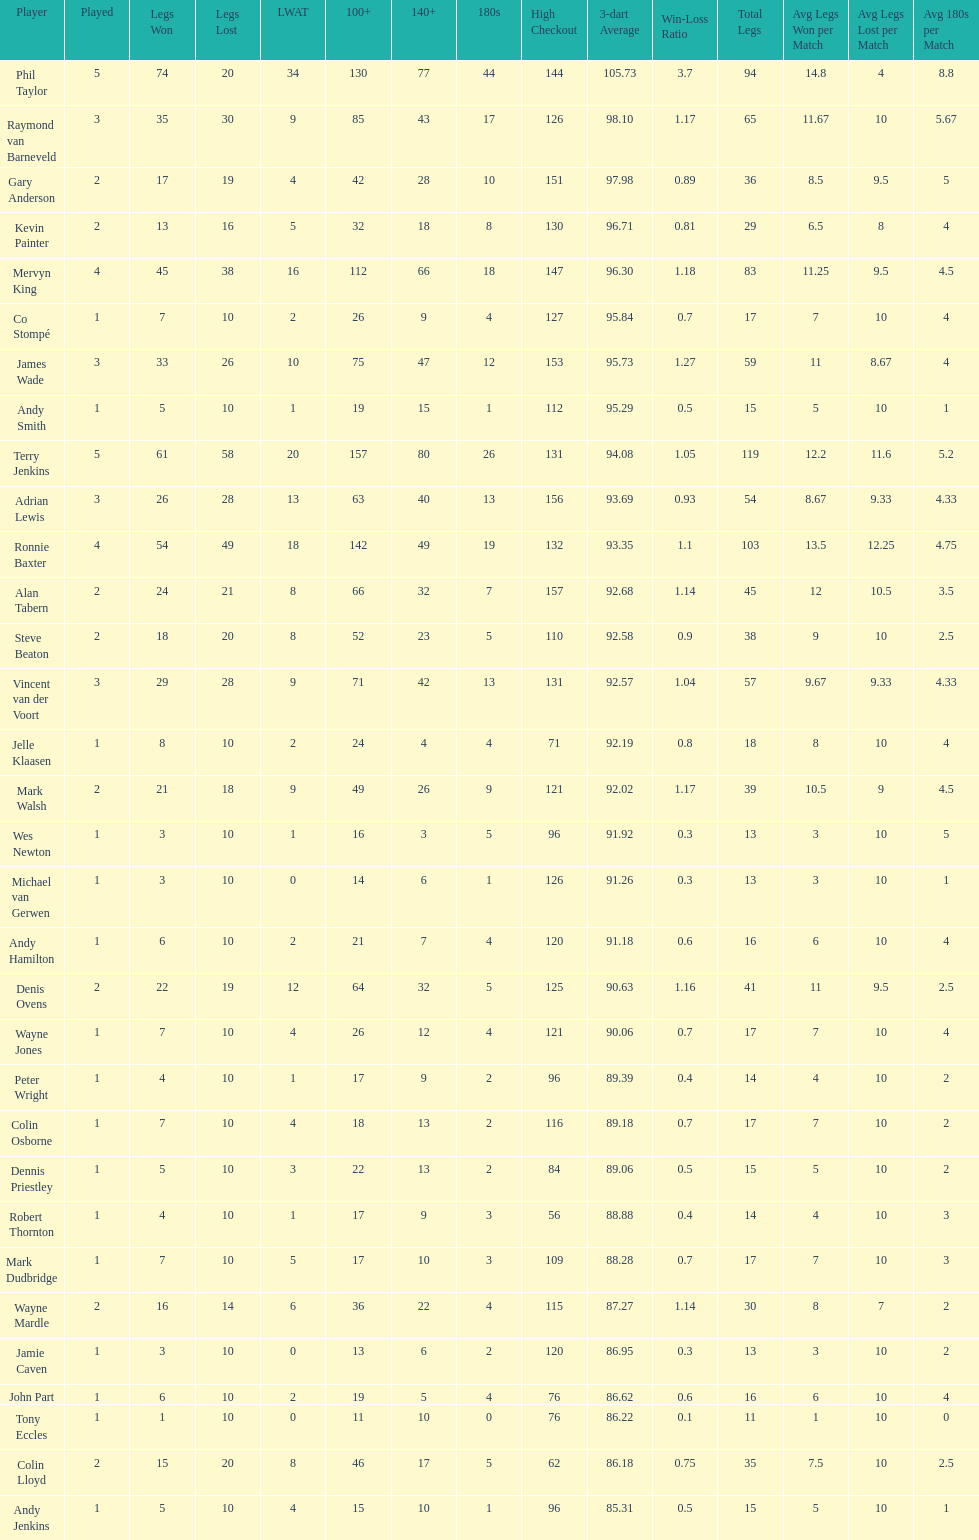Can you parse all the data within this table? {'header': ['Player', 'Played', 'Legs Won', 'Legs Lost', 'LWAT', '100+', '140+', '180s', 'High Checkout', '3-dart Average', 'Win-Loss Ratio', 'Total Legs', 'Avg Legs Won per Match', 'Avg Legs Lost per Match', 'Avg 180s per Match'], 'rows': [['Phil Taylor', '5', '74', '20', '34', '130', '77', '44', '144', '105.73', '3.7', '94', '14.8', '4', '8.8'], ['Raymond van Barneveld', '3', '35', '30', '9', '85', '43', '17', '126', '98.10', '1.17', '65', '11.67', '10', '5.67'], ['Gary Anderson', '2', '17', '19', '4', '42', '28', '10', '151', '97.98', '0.89', '36', '8.5', '9.5', '5'], ['Kevin Painter', '2', '13', '16', '5', '32', '18', '8', '130', '96.71', '0.81', '29', '6.5', '8', '4'], ['Mervyn King', '4', '45', '38', '16', '112', '66', '18', '147', '96.30', '1.18', '83', '11.25', '9.5', '4.5'], ['Co Stompé', '1', '7', '10', '2', '26', '9', '4', '127', '95.84', '0.7', '17', '7', '10', '4'], ['James Wade', '3', '33', '26', '10', '75', '47', '12', '153', '95.73', '1.27', '59', '11', '8.67', '4'], ['Andy Smith', '1', '5', '10', '1', '19', '15', '1', '112', '95.29', '0.5', '15', '5', '10', '1'], ['Terry Jenkins', '5', '61', '58', '20', '157', '80', '26', '131', '94.08', '1.05', '119', '12.2', '11.6', '5.2'], ['Adrian Lewis', '3', '26', '28', '13', '63', '40', '13', '156', '93.69', '0.93', '54', '8.67', '9.33', '4.33'], ['Ronnie Baxter', '4', '54', '49', '18', '142', '49', '19', '132', '93.35', '1.1', '103', '13.5', '12.25', '4.75'], ['Alan Tabern', '2', '24', '21', '8', '66', '32', '7', '157', '92.68', '1.14', '45', '12', '10.5', '3.5'], ['Steve Beaton', '2', '18', '20', '8', '52', '23', '5', '110', '92.58', '0.9', '38', '9', '10', '2.5'], ['Vincent van der Voort', '3', '29', '28', '9', '71', '42', '13', '131', '92.57', '1.04', '57', '9.67', '9.33', '4.33'], ['Jelle Klaasen', '1', '8', '10', '2', '24', '4', '4', '71', '92.19', '0.8', '18', '8', '10', '4'], ['Mark Walsh', '2', '21', '18', '9', '49', '26', '9', '121', '92.02', '1.17', '39', '10.5', '9', '4.5'], ['Wes Newton', '1', '3', '10', '1', '16', '3', '5', '96', '91.92', '0.3', '13', '3', '10', '5'], ['Michael van Gerwen', '1', '3', '10', '0', '14', '6', '1', '126', '91.26', '0.3', '13', '3', '10', '1'], ['Andy Hamilton', '1', '6', '10', '2', '21', '7', '4', '120', '91.18', '0.6', '16', '6', '10', '4'], ['Denis Ovens', '2', '22', '19', '12', '64', '32', '5', '125', '90.63', '1.16', '41', '11', '9.5', '2.5'], ['Wayne Jones', '1', '7', '10', '4', '26', '12', '4', '121', '90.06', '0.7', '17', '7', '10', '4'], ['Peter Wright', '1', '4', '10', '1', '17', '9', '2', '96', '89.39', '0.4', '14', '4', '10', '2'], ['Colin Osborne', '1', '7', '10', '4', '18', '13', '2', '116', '89.18', '0.7', '17', '7', '10', '2'], ['Dennis Priestley', '1', '5', '10', '3', '22', '13', '2', '84', '89.06', '0.5', '15', '5', '10', '2'], ['Robert Thornton', '1', '4', '10', '1', '17', '9', '3', '56', '88.88', '0.4', '14', '4', '10', '3'], ['Mark Dudbridge', '1', '7', '10', '5', '17', '10', '3', '109', '88.28', '0.7', '17', '7', '10', '3'], ['Wayne Mardle', '2', '16', '14', '6', '36', '22', '4', '115', '87.27', '1.14', '30', '8', '7', '2'], ['Jamie Caven', '1', '3', '10', '0', '13', '6', '2', '120', '86.95', '0.3', '13', '3', '10', '2'], ['John Part', '1', '6', '10', '2', '19', '5', '4', '76', '86.62', '0.6', '16', '6', '10', '4'], ['Tony Eccles', '1', '1', '10', '0', '11', '10', '0', '76', '86.22', '0.1', '11', '1', '10', '0'], ['Colin Lloyd', '2', '15', '20', '8', '46', '17', '5', '62', '86.18', '0.75', '35', '7.5', '10', '2.5'], ['Andy Jenkins', '1', '5', '10', '4', '15', '10', '1', '96', '85.31', '0.5', '15', '5', '10', '1']]} How many players in the 2009 world matchplay won at least 30 legs? 6. 